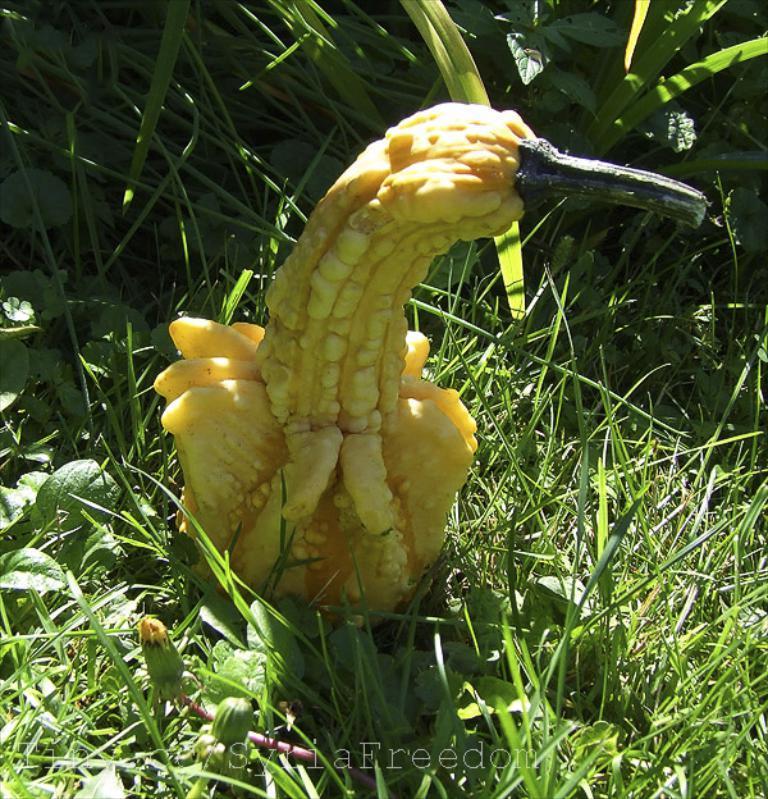How would you summarize this image in a sentence or two? Here we can see vegetable,grass and plants. 